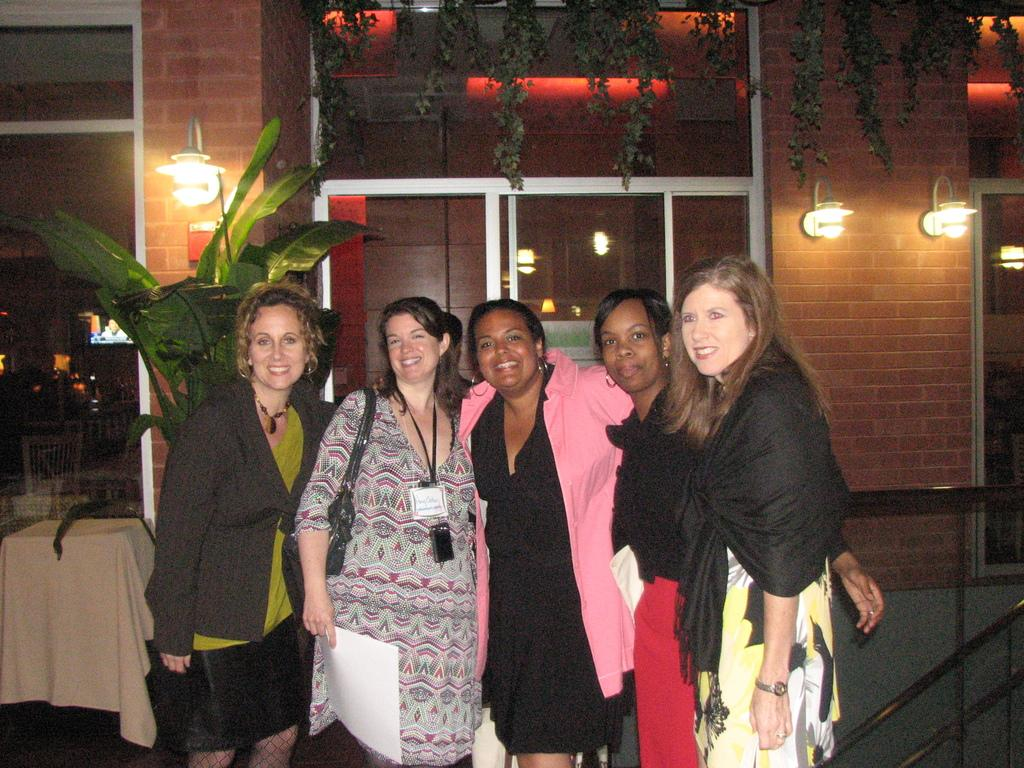Who is present in the image? There are women in the image. What expression do the women have? The women have smiles on their faces. What can be seen on the wall in the background? There are lights on the wall in the background. What type of vegetation is visible in the background? There are plants in the background. What architectural feature is present in the background? There is a door in the background. What type of insect can be seen crawling on the women's faces in the image? There are no insects present on the women's faces in the image. 